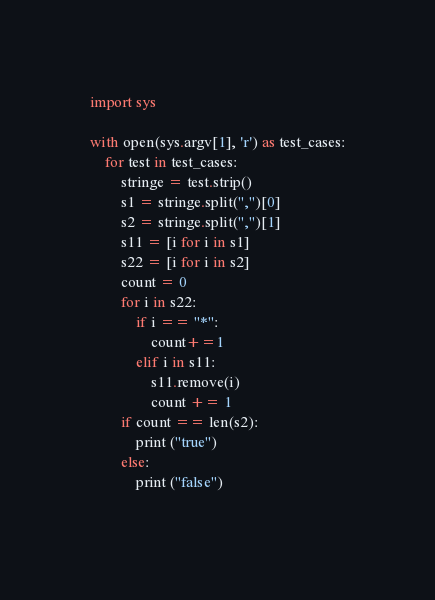<code> <loc_0><loc_0><loc_500><loc_500><_Python_>
import sys

with open(sys.argv[1], 'r') as test_cases:
    for test in test_cases:
        stringe = test.strip()
        s1 = stringe.split(",")[0]
        s2 = stringe.split(",")[1]
        s11 = [i for i in s1]
        s22 = [i for i in s2]
        count = 0
        for i in s22:
            if i == "*":
                count+=1
            elif i in s11:
                s11.remove(i)
                count += 1
        if count == len(s2):
            print ("true")
        else:
            print ("false")
            </code> 